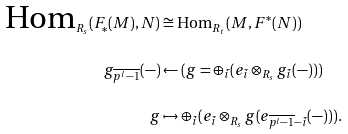<formula> <loc_0><loc_0><loc_500><loc_500>\text {Hom} _ { R _ { s } } ( F _ { * } ( M ) , N ) & \cong \text {Hom} _ { R _ { t } } ( M , F ^ { * } ( N ) ) \\ g _ { \overline { p ^ { l } - 1 } } ( - ) & \leftarrow ( g = \oplus _ { \bar { i } } ( e _ { \bar { i } } \otimes _ { R _ { s } } g _ { \bar { i } } ( - ) ) ) \\ g & \mapsto \oplus _ { \bar { i } } ( e _ { \bar { i } } \otimes _ { R _ { s } } g ( e _ { \overline { p ^ { l } - 1 } - \bar { i } } ( - ) ) ) .</formula> 